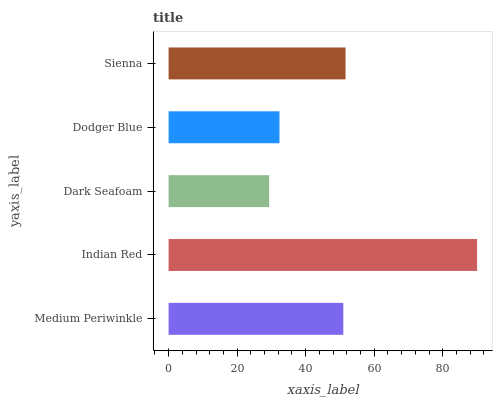Is Dark Seafoam the minimum?
Answer yes or no. Yes. Is Indian Red the maximum?
Answer yes or no. Yes. Is Indian Red the minimum?
Answer yes or no. No. Is Dark Seafoam the maximum?
Answer yes or no. No. Is Indian Red greater than Dark Seafoam?
Answer yes or no. Yes. Is Dark Seafoam less than Indian Red?
Answer yes or no. Yes. Is Dark Seafoam greater than Indian Red?
Answer yes or no. No. Is Indian Red less than Dark Seafoam?
Answer yes or no. No. Is Medium Periwinkle the high median?
Answer yes or no. Yes. Is Medium Periwinkle the low median?
Answer yes or no. Yes. Is Dodger Blue the high median?
Answer yes or no. No. Is Indian Red the low median?
Answer yes or no. No. 